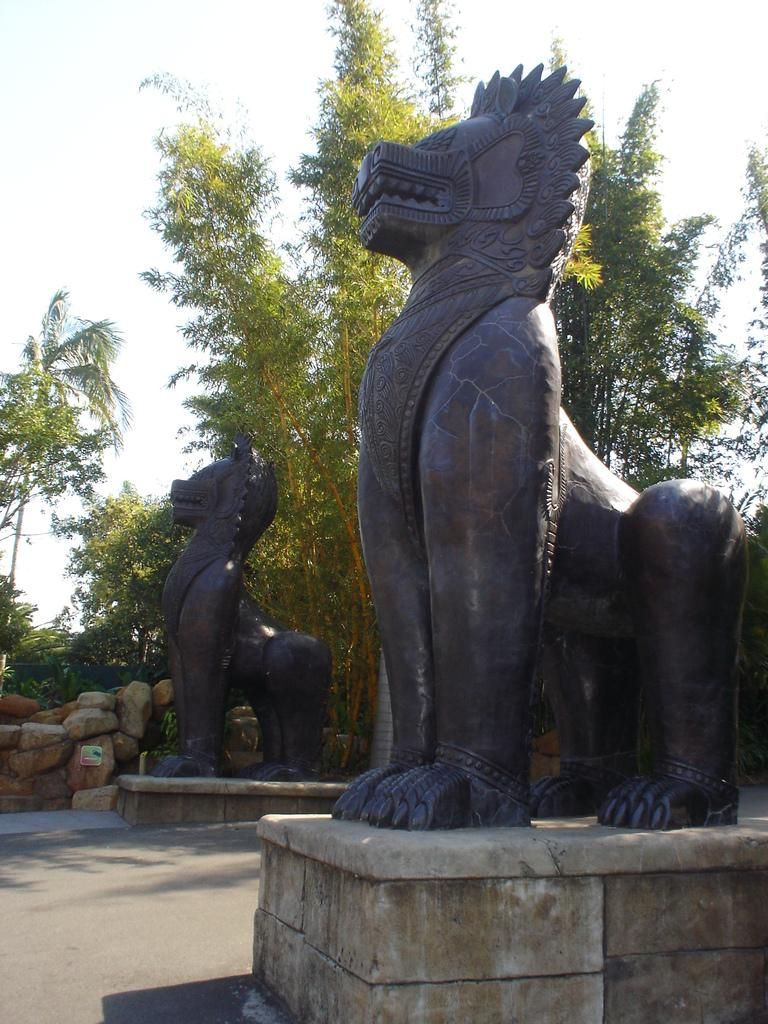What type of objects are in the image? There are statues and stones in the image. What type of natural elements are in the image? There are trees in the image. What is visible in the background of the image? The sky is visible in the background of the image. Can you tell me how many lawyers are present in the image? There are no lawyers present in the image; it features statues, stones, and trees. Is there a lake visible in the image? There is no lake present in the image. 